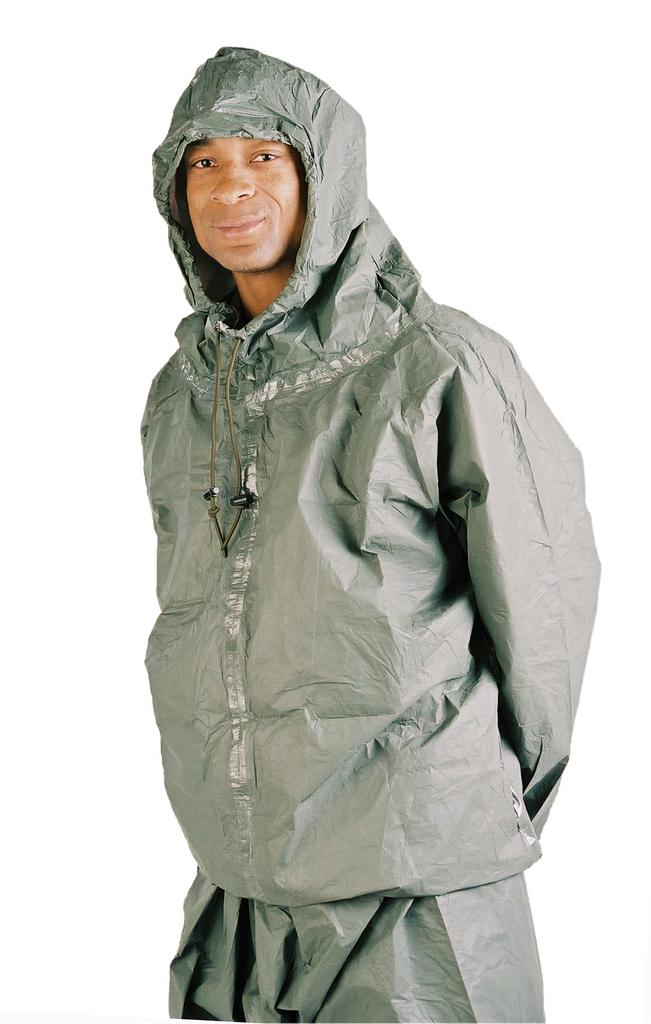Who is the main subject in the image? There is a man in the image. Where is the man located in the image? The man is in the middle of the image. What type of clothing is the man wearing? The man is wearing a coat and a cap. What type of guitar is the man playing in the image? There is no guitar present in the image; the man is not playing any instrument. 